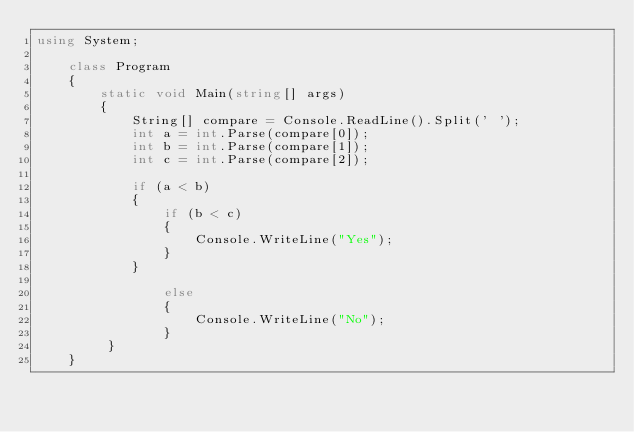<code> <loc_0><loc_0><loc_500><loc_500><_C#_>using System;

    class Program
    {
        static void Main(string[] args)
        {
            String[] compare = Console.ReadLine().Split(' ');
            int a = int.Parse(compare[0]);
            int b = int.Parse(compare[1]);
            int c = int.Parse(compare[2]);

            if (a < b)
            {
                if (b < c)
                {
                    Console.WriteLine("Yes");
                }
            }

                else
                {
                    Console.WriteLine("No");
                }
         }
    }  </code> 